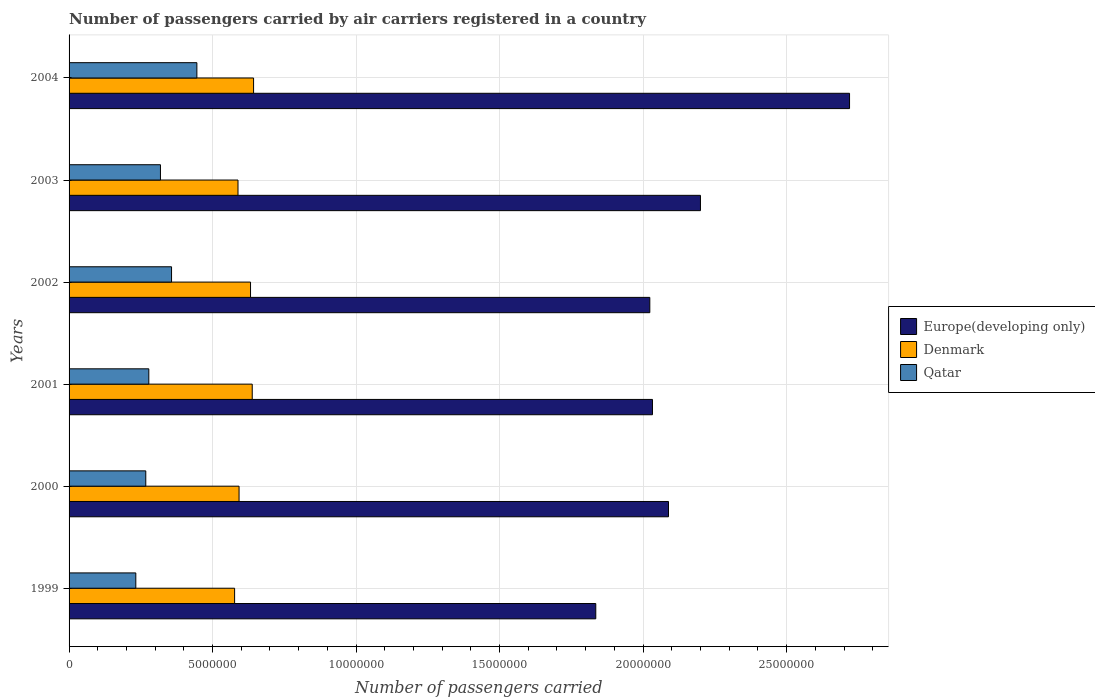How many bars are there on the 6th tick from the bottom?
Offer a very short reply. 3. In how many cases, is the number of bars for a given year not equal to the number of legend labels?
Give a very brief answer. 0. What is the number of passengers carried by air carriers in Denmark in 2003?
Ensure brevity in your answer.  5.89e+06. Across all years, what is the maximum number of passengers carried by air carriers in Denmark?
Make the answer very short. 6.43e+06. Across all years, what is the minimum number of passengers carried by air carriers in Denmark?
Offer a terse response. 5.77e+06. In which year was the number of passengers carried by air carriers in Qatar maximum?
Provide a succinct answer. 2004. What is the total number of passengers carried by air carriers in Denmark in the graph?
Keep it short and to the point. 3.67e+07. What is the difference between the number of passengers carried by air carriers in Qatar in 1999 and that in 2004?
Offer a very short reply. -2.13e+06. What is the difference between the number of passengers carried by air carriers in Qatar in 1999 and the number of passengers carried by air carriers in Europe(developing only) in 2002?
Offer a terse response. -1.79e+07. What is the average number of passengers carried by air carriers in Qatar per year?
Keep it short and to the point. 3.16e+06. In the year 1999, what is the difference between the number of passengers carried by air carriers in Europe(developing only) and number of passengers carried by air carriers in Qatar?
Offer a terse response. 1.60e+07. In how many years, is the number of passengers carried by air carriers in Qatar greater than 5000000 ?
Your response must be concise. 0. What is the ratio of the number of passengers carried by air carriers in Qatar in 1999 to that in 2003?
Your response must be concise. 0.73. Is the number of passengers carried by air carriers in Qatar in 1999 less than that in 2004?
Offer a very short reply. Yes. Is the difference between the number of passengers carried by air carriers in Europe(developing only) in 2002 and 2003 greater than the difference between the number of passengers carried by air carriers in Qatar in 2002 and 2003?
Keep it short and to the point. No. What is the difference between the highest and the second highest number of passengers carried by air carriers in Europe(developing only)?
Make the answer very short. 5.19e+06. What is the difference between the highest and the lowest number of passengers carried by air carriers in Denmark?
Your answer should be very brief. 6.61e+05. Is the sum of the number of passengers carried by air carriers in Denmark in 2000 and 2004 greater than the maximum number of passengers carried by air carriers in Qatar across all years?
Ensure brevity in your answer.  Yes. What does the 3rd bar from the top in 2002 represents?
Provide a short and direct response. Europe(developing only). Is it the case that in every year, the sum of the number of passengers carried by air carriers in Europe(developing only) and number of passengers carried by air carriers in Qatar is greater than the number of passengers carried by air carriers in Denmark?
Offer a very short reply. Yes. Are all the bars in the graph horizontal?
Offer a very short reply. Yes. How many years are there in the graph?
Your answer should be very brief. 6. What is the difference between two consecutive major ticks on the X-axis?
Ensure brevity in your answer.  5.00e+06. Where does the legend appear in the graph?
Your response must be concise. Center right. What is the title of the graph?
Provide a succinct answer. Number of passengers carried by air carriers registered in a country. What is the label or title of the X-axis?
Make the answer very short. Number of passengers carried. What is the Number of passengers carried of Europe(developing only) in 1999?
Provide a succinct answer. 1.84e+07. What is the Number of passengers carried in Denmark in 1999?
Keep it short and to the point. 5.77e+06. What is the Number of passengers carried of Qatar in 1999?
Offer a terse response. 2.33e+06. What is the Number of passengers carried of Europe(developing only) in 2000?
Your answer should be compact. 2.09e+07. What is the Number of passengers carried in Denmark in 2000?
Provide a succinct answer. 5.92e+06. What is the Number of passengers carried in Qatar in 2000?
Your answer should be compact. 2.67e+06. What is the Number of passengers carried of Europe(developing only) in 2001?
Your response must be concise. 2.03e+07. What is the Number of passengers carried in Denmark in 2001?
Keep it short and to the point. 6.38e+06. What is the Number of passengers carried in Qatar in 2001?
Your response must be concise. 2.78e+06. What is the Number of passengers carried in Europe(developing only) in 2002?
Provide a short and direct response. 2.02e+07. What is the Number of passengers carried of Denmark in 2002?
Ensure brevity in your answer.  6.32e+06. What is the Number of passengers carried in Qatar in 2002?
Your answer should be compact. 3.57e+06. What is the Number of passengers carried in Europe(developing only) in 2003?
Offer a terse response. 2.20e+07. What is the Number of passengers carried of Denmark in 2003?
Offer a terse response. 5.89e+06. What is the Number of passengers carried of Qatar in 2003?
Offer a very short reply. 3.18e+06. What is the Number of passengers carried of Europe(developing only) in 2004?
Give a very brief answer. 2.72e+07. What is the Number of passengers carried in Denmark in 2004?
Offer a very short reply. 6.43e+06. What is the Number of passengers carried in Qatar in 2004?
Provide a succinct answer. 4.45e+06. Across all years, what is the maximum Number of passengers carried in Europe(developing only)?
Ensure brevity in your answer.  2.72e+07. Across all years, what is the maximum Number of passengers carried in Denmark?
Your answer should be very brief. 6.43e+06. Across all years, what is the maximum Number of passengers carried of Qatar?
Your answer should be compact. 4.45e+06. Across all years, what is the minimum Number of passengers carried of Europe(developing only)?
Your response must be concise. 1.84e+07. Across all years, what is the minimum Number of passengers carried of Denmark?
Make the answer very short. 5.77e+06. Across all years, what is the minimum Number of passengers carried in Qatar?
Keep it short and to the point. 2.33e+06. What is the total Number of passengers carried of Europe(developing only) in the graph?
Keep it short and to the point. 1.29e+08. What is the total Number of passengers carried of Denmark in the graph?
Offer a very short reply. 3.67e+07. What is the total Number of passengers carried in Qatar in the graph?
Provide a succinct answer. 1.90e+07. What is the difference between the Number of passengers carried in Europe(developing only) in 1999 and that in 2000?
Offer a very short reply. -2.53e+06. What is the difference between the Number of passengers carried of Denmark in 1999 and that in 2000?
Provide a succinct answer. -1.55e+05. What is the difference between the Number of passengers carried in Qatar in 1999 and that in 2000?
Offer a very short reply. -3.48e+05. What is the difference between the Number of passengers carried of Europe(developing only) in 1999 and that in 2001?
Your response must be concise. -1.98e+06. What is the difference between the Number of passengers carried of Denmark in 1999 and that in 2001?
Offer a terse response. -6.14e+05. What is the difference between the Number of passengers carried of Qatar in 1999 and that in 2001?
Offer a very short reply. -4.53e+05. What is the difference between the Number of passengers carried of Europe(developing only) in 1999 and that in 2002?
Your answer should be very brief. -1.88e+06. What is the difference between the Number of passengers carried in Denmark in 1999 and that in 2002?
Give a very brief answer. -5.55e+05. What is the difference between the Number of passengers carried of Qatar in 1999 and that in 2002?
Keep it short and to the point. -1.25e+06. What is the difference between the Number of passengers carried in Europe(developing only) in 1999 and that in 2003?
Ensure brevity in your answer.  -3.65e+06. What is the difference between the Number of passengers carried of Denmark in 1999 and that in 2003?
Your answer should be compact. -1.18e+05. What is the difference between the Number of passengers carried of Qatar in 1999 and that in 2003?
Offer a very short reply. -8.59e+05. What is the difference between the Number of passengers carried in Europe(developing only) in 1999 and that in 2004?
Provide a succinct answer. -8.84e+06. What is the difference between the Number of passengers carried in Denmark in 1999 and that in 2004?
Your response must be concise. -6.61e+05. What is the difference between the Number of passengers carried of Qatar in 1999 and that in 2004?
Provide a short and direct response. -2.13e+06. What is the difference between the Number of passengers carried in Europe(developing only) in 2000 and that in 2001?
Your answer should be very brief. 5.58e+05. What is the difference between the Number of passengers carried of Denmark in 2000 and that in 2001?
Offer a very short reply. -4.59e+05. What is the difference between the Number of passengers carried of Qatar in 2000 and that in 2001?
Keep it short and to the point. -1.05e+05. What is the difference between the Number of passengers carried of Europe(developing only) in 2000 and that in 2002?
Make the answer very short. 6.51e+05. What is the difference between the Number of passengers carried in Denmark in 2000 and that in 2002?
Offer a terse response. -4.00e+05. What is the difference between the Number of passengers carried in Qatar in 2000 and that in 2002?
Your answer should be very brief. -8.98e+05. What is the difference between the Number of passengers carried in Europe(developing only) in 2000 and that in 2003?
Offer a terse response. -1.11e+06. What is the difference between the Number of passengers carried of Denmark in 2000 and that in 2003?
Keep it short and to the point. 3.66e+04. What is the difference between the Number of passengers carried in Qatar in 2000 and that in 2003?
Offer a very short reply. -5.11e+05. What is the difference between the Number of passengers carried of Europe(developing only) in 2000 and that in 2004?
Give a very brief answer. -6.31e+06. What is the difference between the Number of passengers carried of Denmark in 2000 and that in 2004?
Offer a very short reply. -5.06e+05. What is the difference between the Number of passengers carried in Qatar in 2000 and that in 2004?
Your answer should be very brief. -1.78e+06. What is the difference between the Number of passengers carried of Europe(developing only) in 2001 and that in 2002?
Offer a very short reply. 9.29e+04. What is the difference between the Number of passengers carried of Denmark in 2001 and that in 2002?
Your response must be concise. 5.97e+04. What is the difference between the Number of passengers carried of Qatar in 2001 and that in 2002?
Your response must be concise. -7.92e+05. What is the difference between the Number of passengers carried of Europe(developing only) in 2001 and that in 2003?
Offer a very short reply. -1.67e+06. What is the difference between the Number of passengers carried in Denmark in 2001 and that in 2003?
Provide a short and direct response. 4.96e+05. What is the difference between the Number of passengers carried of Qatar in 2001 and that in 2003?
Keep it short and to the point. -4.06e+05. What is the difference between the Number of passengers carried in Europe(developing only) in 2001 and that in 2004?
Make the answer very short. -6.87e+06. What is the difference between the Number of passengers carried in Denmark in 2001 and that in 2004?
Offer a terse response. -4.66e+04. What is the difference between the Number of passengers carried in Qatar in 2001 and that in 2004?
Your response must be concise. -1.67e+06. What is the difference between the Number of passengers carried of Europe(developing only) in 2002 and that in 2003?
Offer a terse response. -1.76e+06. What is the difference between the Number of passengers carried in Denmark in 2002 and that in 2003?
Offer a very short reply. 4.36e+05. What is the difference between the Number of passengers carried of Qatar in 2002 and that in 2003?
Offer a terse response. 3.86e+05. What is the difference between the Number of passengers carried of Europe(developing only) in 2002 and that in 2004?
Your response must be concise. -6.96e+06. What is the difference between the Number of passengers carried in Denmark in 2002 and that in 2004?
Provide a short and direct response. -1.06e+05. What is the difference between the Number of passengers carried in Qatar in 2002 and that in 2004?
Provide a short and direct response. -8.83e+05. What is the difference between the Number of passengers carried of Europe(developing only) in 2003 and that in 2004?
Provide a short and direct response. -5.19e+06. What is the difference between the Number of passengers carried in Denmark in 2003 and that in 2004?
Your response must be concise. -5.43e+05. What is the difference between the Number of passengers carried of Qatar in 2003 and that in 2004?
Offer a very short reply. -1.27e+06. What is the difference between the Number of passengers carried in Europe(developing only) in 1999 and the Number of passengers carried in Denmark in 2000?
Provide a succinct answer. 1.24e+07. What is the difference between the Number of passengers carried in Europe(developing only) in 1999 and the Number of passengers carried in Qatar in 2000?
Offer a very short reply. 1.57e+07. What is the difference between the Number of passengers carried in Denmark in 1999 and the Number of passengers carried in Qatar in 2000?
Your answer should be very brief. 3.09e+06. What is the difference between the Number of passengers carried in Europe(developing only) in 1999 and the Number of passengers carried in Denmark in 2001?
Ensure brevity in your answer.  1.20e+07. What is the difference between the Number of passengers carried of Europe(developing only) in 1999 and the Number of passengers carried of Qatar in 2001?
Give a very brief answer. 1.56e+07. What is the difference between the Number of passengers carried of Denmark in 1999 and the Number of passengers carried of Qatar in 2001?
Your answer should be compact. 2.99e+06. What is the difference between the Number of passengers carried of Europe(developing only) in 1999 and the Number of passengers carried of Denmark in 2002?
Offer a very short reply. 1.20e+07. What is the difference between the Number of passengers carried in Europe(developing only) in 1999 and the Number of passengers carried in Qatar in 2002?
Your answer should be very brief. 1.48e+07. What is the difference between the Number of passengers carried in Denmark in 1999 and the Number of passengers carried in Qatar in 2002?
Provide a succinct answer. 2.20e+06. What is the difference between the Number of passengers carried of Europe(developing only) in 1999 and the Number of passengers carried of Denmark in 2003?
Ensure brevity in your answer.  1.25e+07. What is the difference between the Number of passengers carried of Europe(developing only) in 1999 and the Number of passengers carried of Qatar in 2003?
Give a very brief answer. 1.52e+07. What is the difference between the Number of passengers carried of Denmark in 1999 and the Number of passengers carried of Qatar in 2003?
Your answer should be compact. 2.58e+06. What is the difference between the Number of passengers carried of Europe(developing only) in 1999 and the Number of passengers carried of Denmark in 2004?
Give a very brief answer. 1.19e+07. What is the difference between the Number of passengers carried in Europe(developing only) in 1999 and the Number of passengers carried in Qatar in 2004?
Ensure brevity in your answer.  1.39e+07. What is the difference between the Number of passengers carried in Denmark in 1999 and the Number of passengers carried in Qatar in 2004?
Provide a succinct answer. 1.31e+06. What is the difference between the Number of passengers carried in Europe(developing only) in 2000 and the Number of passengers carried in Denmark in 2001?
Keep it short and to the point. 1.45e+07. What is the difference between the Number of passengers carried in Europe(developing only) in 2000 and the Number of passengers carried in Qatar in 2001?
Your response must be concise. 1.81e+07. What is the difference between the Number of passengers carried of Denmark in 2000 and the Number of passengers carried of Qatar in 2001?
Your answer should be very brief. 3.14e+06. What is the difference between the Number of passengers carried of Europe(developing only) in 2000 and the Number of passengers carried of Denmark in 2002?
Keep it short and to the point. 1.46e+07. What is the difference between the Number of passengers carried of Europe(developing only) in 2000 and the Number of passengers carried of Qatar in 2002?
Offer a very short reply. 1.73e+07. What is the difference between the Number of passengers carried of Denmark in 2000 and the Number of passengers carried of Qatar in 2002?
Your answer should be compact. 2.35e+06. What is the difference between the Number of passengers carried in Europe(developing only) in 2000 and the Number of passengers carried in Denmark in 2003?
Offer a terse response. 1.50e+07. What is the difference between the Number of passengers carried in Europe(developing only) in 2000 and the Number of passengers carried in Qatar in 2003?
Ensure brevity in your answer.  1.77e+07. What is the difference between the Number of passengers carried of Denmark in 2000 and the Number of passengers carried of Qatar in 2003?
Offer a terse response. 2.74e+06. What is the difference between the Number of passengers carried of Europe(developing only) in 2000 and the Number of passengers carried of Denmark in 2004?
Your response must be concise. 1.45e+07. What is the difference between the Number of passengers carried in Europe(developing only) in 2000 and the Number of passengers carried in Qatar in 2004?
Your answer should be very brief. 1.64e+07. What is the difference between the Number of passengers carried of Denmark in 2000 and the Number of passengers carried of Qatar in 2004?
Provide a short and direct response. 1.47e+06. What is the difference between the Number of passengers carried of Europe(developing only) in 2001 and the Number of passengers carried of Denmark in 2002?
Provide a short and direct response. 1.40e+07. What is the difference between the Number of passengers carried in Europe(developing only) in 2001 and the Number of passengers carried in Qatar in 2002?
Your response must be concise. 1.68e+07. What is the difference between the Number of passengers carried of Denmark in 2001 and the Number of passengers carried of Qatar in 2002?
Give a very brief answer. 2.81e+06. What is the difference between the Number of passengers carried of Europe(developing only) in 2001 and the Number of passengers carried of Denmark in 2003?
Your response must be concise. 1.44e+07. What is the difference between the Number of passengers carried in Europe(developing only) in 2001 and the Number of passengers carried in Qatar in 2003?
Offer a terse response. 1.71e+07. What is the difference between the Number of passengers carried of Denmark in 2001 and the Number of passengers carried of Qatar in 2003?
Ensure brevity in your answer.  3.20e+06. What is the difference between the Number of passengers carried of Europe(developing only) in 2001 and the Number of passengers carried of Denmark in 2004?
Your answer should be compact. 1.39e+07. What is the difference between the Number of passengers carried in Europe(developing only) in 2001 and the Number of passengers carried in Qatar in 2004?
Offer a very short reply. 1.59e+07. What is the difference between the Number of passengers carried of Denmark in 2001 and the Number of passengers carried of Qatar in 2004?
Your answer should be very brief. 1.93e+06. What is the difference between the Number of passengers carried in Europe(developing only) in 2002 and the Number of passengers carried in Denmark in 2003?
Offer a terse response. 1.43e+07. What is the difference between the Number of passengers carried of Europe(developing only) in 2002 and the Number of passengers carried of Qatar in 2003?
Provide a short and direct response. 1.71e+07. What is the difference between the Number of passengers carried in Denmark in 2002 and the Number of passengers carried in Qatar in 2003?
Give a very brief answer. 3.14e+06. What is the difference between the Number of passengers carried of Europe(developing only) in 2002 and the Number of passengers carried of Denmark in 2004?
Provide a short and direct response. 1.38e+07. What is the difference between the Number of passengers carried in Europe(developing only) in 2002 and the Number of passengers carried in Qatar in 2004?
Make the answer very short. 1.58e+07. What is the difference between the Number of passengers carried in Denmark in 2002 and the Number of passengers carried in Qatar in 2004?
Your response must be concise. 1.87e+06. What is the difference between the Number of passengers carried in Europe(developing only) in 2003 and the Number of passengers carried in Denmark in 2004?
Offer a very short reply. 1.56e+07. What is the difference between the Number of passengers carried of Europe(developing only) in 2003 and the Number of passengers carried of Qatar in 2004?
Provide a short and direct response. 1.75e+07. What is the difference between the Number of passengers carried in Denmark in 2003 and the Number of passengers carried in Qatar in 2004?
Your answer should be compact. 1.43e+06. What is the average Number of passengers carried in Europe(developing only) per year?
Your answer should be very brief. 2.15e+07. What is the average Number of passengers carried of Denmark per year?
Provide a short and direct response. 6.12e+06. What is the average Number of passengers carried of Qatar per year?
Provide a succinct answer. 3.16e+06. In the year 1999, what is the difference between the Number of passengers carried of Europe(developing only) and Number of passengers carried of Denmark?
Make the answer very short. 1.26e+07. In the year 1999, what is the difference between the Number of passengers carried of Europe(developing only) and Number of passengers carried of Qatar?
Offer a very short reply. 1.60e+07. In the year 1999, what is the difference between the Number of passengers carried in Denmark and Number of passengers carried in Qatar?
Provide a succinct answer. 3.44e+06. In the year 2000, what is the difference between the Number of passengers carried of Europe(developing only) and Number of passengers carried of Denmark?
Your response must be concise. 1.50e+07. In the year 2000, what is the difference between the Number of passengers carried in Europe(developing only) and Number of passengers carried in Qatar?
Provide a succinct answer. 1.82e+07. In the year 2000, what is the difference between the Number of passengers carried in Denmark and Number of passengers carried in Qatar?
Offer a terse response. 3.25e+06. In the year 2001, what is the difference between the Number of passengers carried of Europe(developing only) and Number of passengers carried of Denmark?
Keep it short and to the point. 1.39e+07. In the year 2001, what is the difference between the Number of passengers carried of Europe(developing only) and Number of passengers carried of Qatar?
Give a very brief answer. 1.75e+07. In the year 2001, what is the difference between the Number of passengers carried in Denmark and Number of passengers carried in Qatar?
Offer a very short reply. 3.60e+06. In the year 2002, what is the difference between the Number of passengers carried of Europe(developing only) and Number of passengers carried of Denmark?
Offer a terse response. 1.39e+07. In the year 2002, what is the difference between the Number of passengers carried in Europe(developing only) and Number of passengers carried in Qatar?
Ensure brevity in your answer.  1.67e+07. In the year 2002, what is the difference between the Number of passengers carried of Denmark and Number of passengers carried of Qatar?
Your answer should be very brief. 2.75e+06. In the year 2003, what is the difference between the Number of passengers carried of Europe(developing only) and Number of passengers carried of Denmark?
Provide a succinct answer. 1.61e+07. In the year 2003, what is the difference between the Number of passengers carried in Europe(developing only) and Number of passengers carried in Qatar?
Make the answer very short. 1.88e+07. In the year 2003, what is the difference between the Number of passengers carried in Denmark and Number of passengers carried in Qatar?
Offer a very short reply. 2.70e+06. In the year 2004, what is the difference between the Number of passengers carried in Europe(developing only) and Number of passengers carried in Denmark?
Make the answer very short. 2.08e+07. In the year 2004, what is the difference between the Number of passengers carried of Europe(developing only) and Number of passengers carried of Qatar?
Provide a short and direct response. 2.27e+07. In the year 2004, what is the difference between the Number of passengers carried in Denmark and Number of passengers carried in Qatar?
Offer a very short reply. 1.98e+06. What is the ratio of the Number of passengers carried in Europe(developing only) in 1999 to that in 2000?
Provide a short and direct response. 0.88. What is the ratio of the Number of passengers carried in Denmark in 1999 to that in 2000?
Give a very brief answer. 0.97. What is the ratio of the Number of passengers carried in Qatar in 1999 to that in 2000?
Your answer should be very brief. 0.87. What is the ratio of the Number of passengers carried in Europe(developing only) in 1999 to that in 2001?
Provide a succinct answer. 0.9. What is the ratio of the Number of passengers carried of Denmark in 1999 to that in 2001?
Your answer should be compact. 0.9. What is the ratio of the Number of passengers carried of Qatar in 1999 to that in 2001?
Offer a very short reply. 0.84. What is the ratio of the Number of passengers carried of Europe(developing only) in 1999 to that in 2002?
Make the answer very short. 0.91. What is the ratio of the Number of passengers carried in Denmark in 1999 to that in 2002?
Your response must be concise. 0.91. What is the ratio of the Number of passengers carried of Qatar in 1999 to that in 2002?
Keep it short and to the point. 0.65. What is the ratio of the Number of passengers carried of Europe(developing only) in 1999 to that in 2003?
Keep it short and to the point. 0.83. What is the ratio of the Number of passengers carried of Denmark in 1999 to that in 2003?
Provide a succinct answer. 0.98. What is the ratio of the Number of passengers carried of Qatar in 1999 to that in 2003?
Offer a very short reply. 0.73. What is the ratio of the Number of passengers carried in Europe(developing only) in 1999 to that in 2004?
Give a very brief answer. 0.67. What is the ratio of the Number of passengers carried in Denmark in 1999 to that in 2004?
Your answer should be very brief. 0.9. What is the ratio of the Number of passengers carried in Qatar in 1999 to that in 2004?
Your answer should be compact. 0.52. What is the ratio of the Number of passengers carried of Europe(developing only) in 2000 to that in 2001?
Your response must be concise. 1.03. What is the ratio of the Number of passengers carried of Denmark in 2000 to that in 2001?
Make the answer very short. 0.93. What is the ratio of the Number of passengers carried of Qatar in 2000 to that in 2001?
Ensure brevity in your answer.  0.96. What is the ratio of the Number of passengers carried of Europe(developing only) in 2000 to that in 2002?
Your response must be concise. 1.03. What is the ratio of the Number of passengers carried of Denmark in 2000 to that in 2002?
Provide a short and direct response. 0.94. What is the ratio of the Number of passengers carried in Qatar in 2000 to that in 2002?
Ensure brevity in your answer.  0.75. What is the ratio of the Number of passengers carried of Europe(developing only) in 2000 to that in 2003?
Provide a succinct answer. 0.95. What is the ratio of the Number of passengers carried in Qatar in 2000 to that in 2003?
Your response must be concise. 0.84. What is the ratio of the Number of passengers carried of Europe(developing only) in 2000 to that in 2004?
Make the answer very short. 0.77. What is the ratio of the Number of passengers carried in Denmark in 2000 to that in 2004?
Offer a very short reply. 0.92. What is the ratio of the Number of passengers carried of Qatar in 2000 to that in 2004?
Keep it short and to the point. 0.6. What is the ratio of the Number of passengers carried of Europe(developing only) in 2001 to that in 2002?
Keep it short and to the point. 1. What is the ratio of the Number of passengers carried of Denmark in 2001 to that in 2002?
Give a very brief answer. 1.01. What is the ratio of the Number of passengers carried in Qatar in 2001 to that in 2002?
Ensure brevity in your answer.  0.78. What is the ratio of the Number of passengers carried in Europe(developing only) in 2001 to that in 2003?
Offer a terse response. 0.92. What is the ratio of the Number of passengers carried of Denmark in 2001 to that in 2003?
Your answer should be compact. 1.08. What is the ratio of the Number of passengers carried in Qatar in 2001 to that in 2003?
Ensure brevity in your answer.  0.87. What is the ratio of the Number of passengers carried of Europe(developing only) in 2001 to that in 2004?
Keep it short and to the point. 0.75. What is the ratio of the Number of passengers carried in Denmark in 2001 to that in 2004?
Make the answer very short. 0.99. What is the ratio of the Number of passengers carried of Qatar in 2001 to that in 2004?
Keep it short and to the point. 0.62. What is the ratio of the Number of passengers carried of Europe(developing only) in 2002 to that in 2003?
Give a very brief answer. 0.92. What is the ratio of the Number of passengers carried of Denmark in 2002 to that in 2003?
Your answer should be very brief. 1.07. What is the ratio of the Number of passengers carried of Qatar in 2002 to that in 2003?
Ensure brevity in your answer.  1.12. What is the ratio of the Number of passengers carried of Europe(developing only) in 2002 to that in 2004?
Ensure brevity in your answer.  0.74. What is the ratio of the Number of passengers carried of Denmark in 2002 to that in 2004?
Make the answer very short. 0.98. What is the ratio of the Number of passengers carried in Qatar in 2002 to that in 2004?
Give a very brief answer. 0.8. What is the ratio of the Number of passengers carried in Europe(developing only) in 2003 to that in 2004?
Ensure brevity in your answer.  0.81. What is the ratio of the Number of passengers carried of Denmark in 2003 to that in 2004?
Your answer should be very brief. 0.92. What is the ratio of the Number of passengers carried of Qatar in 2003 to that in 2004?
Provide a succinct answer. 0.71. What is the difference between the highest and the second highest Number of passengers carried in Europe(developing only)?
Offer a terse response. 5.19e+06. What is the difference between the highest and the second highest Number of passengers carried of Denmark?
Provide a short and direct response. 4.66e+04. What is the difference between the highest and the second highest Number of passengers carried of Qatar?
Your answer should be compact. 8.83e+05. What is the difference between the highest and the lowest Number of passengers carried of Europe(developing only)?
Give a very brief answer. 8.84e+06. What is the difference between the highest and the lowest Number of passengers carried in Denmark?
Make the answer very short. 6.61e+05. What is the difference between the highest and the lowest Number of passengers carried of Qatar?
Provide a short and direct response. 2.13e+06. 